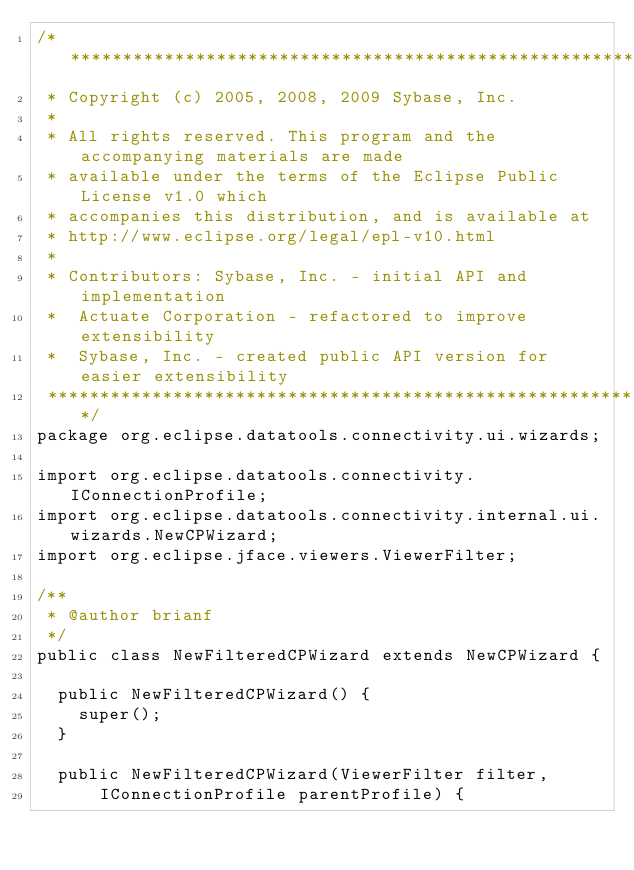Convert code to text. <code><loc_0><loc_0><loc_500><loc_500><_Java_>/*******************************************************************************
 * Copyright (c) 2005, 2008, 2009 Sybase, Inc.
 * 
 * All rights reserved. This program and the accompanying materials are made
 * available under the terms of the Eclipse Public License v1.0 which
 * accompanies this distribution, and is available at
 * http://www.eclipse.org/legal/epl-v10.html
 * 
 * Contributors: Sybase, Inc. - initial API and implementation
 *  Actuate Corporation - refactored to improve extensibility
 *  Sybase, Inc. - created public API version for easier extensibility
 ******************************************************************************/
package org.eclipse.datatools.connectivity.ui.wizards;

import org.eclipse.datatools.connectivity.IConnectionProfile;
import org.eclipse.datatools.connectivity.internal.ui.wizards.NewCPWizard;
import org.eclipse.jface.viewers.ViewerFilter;

/**
 * @author brianf
 */
public class NewFilteredCPWizard extends NewCPWizard {

	public NewFilteredCPWizard() {
		super();
	}

	public NewFilteredCPWizard(ViewerFilter filter,
			IConnectionProfile parentProfile) {</code> 